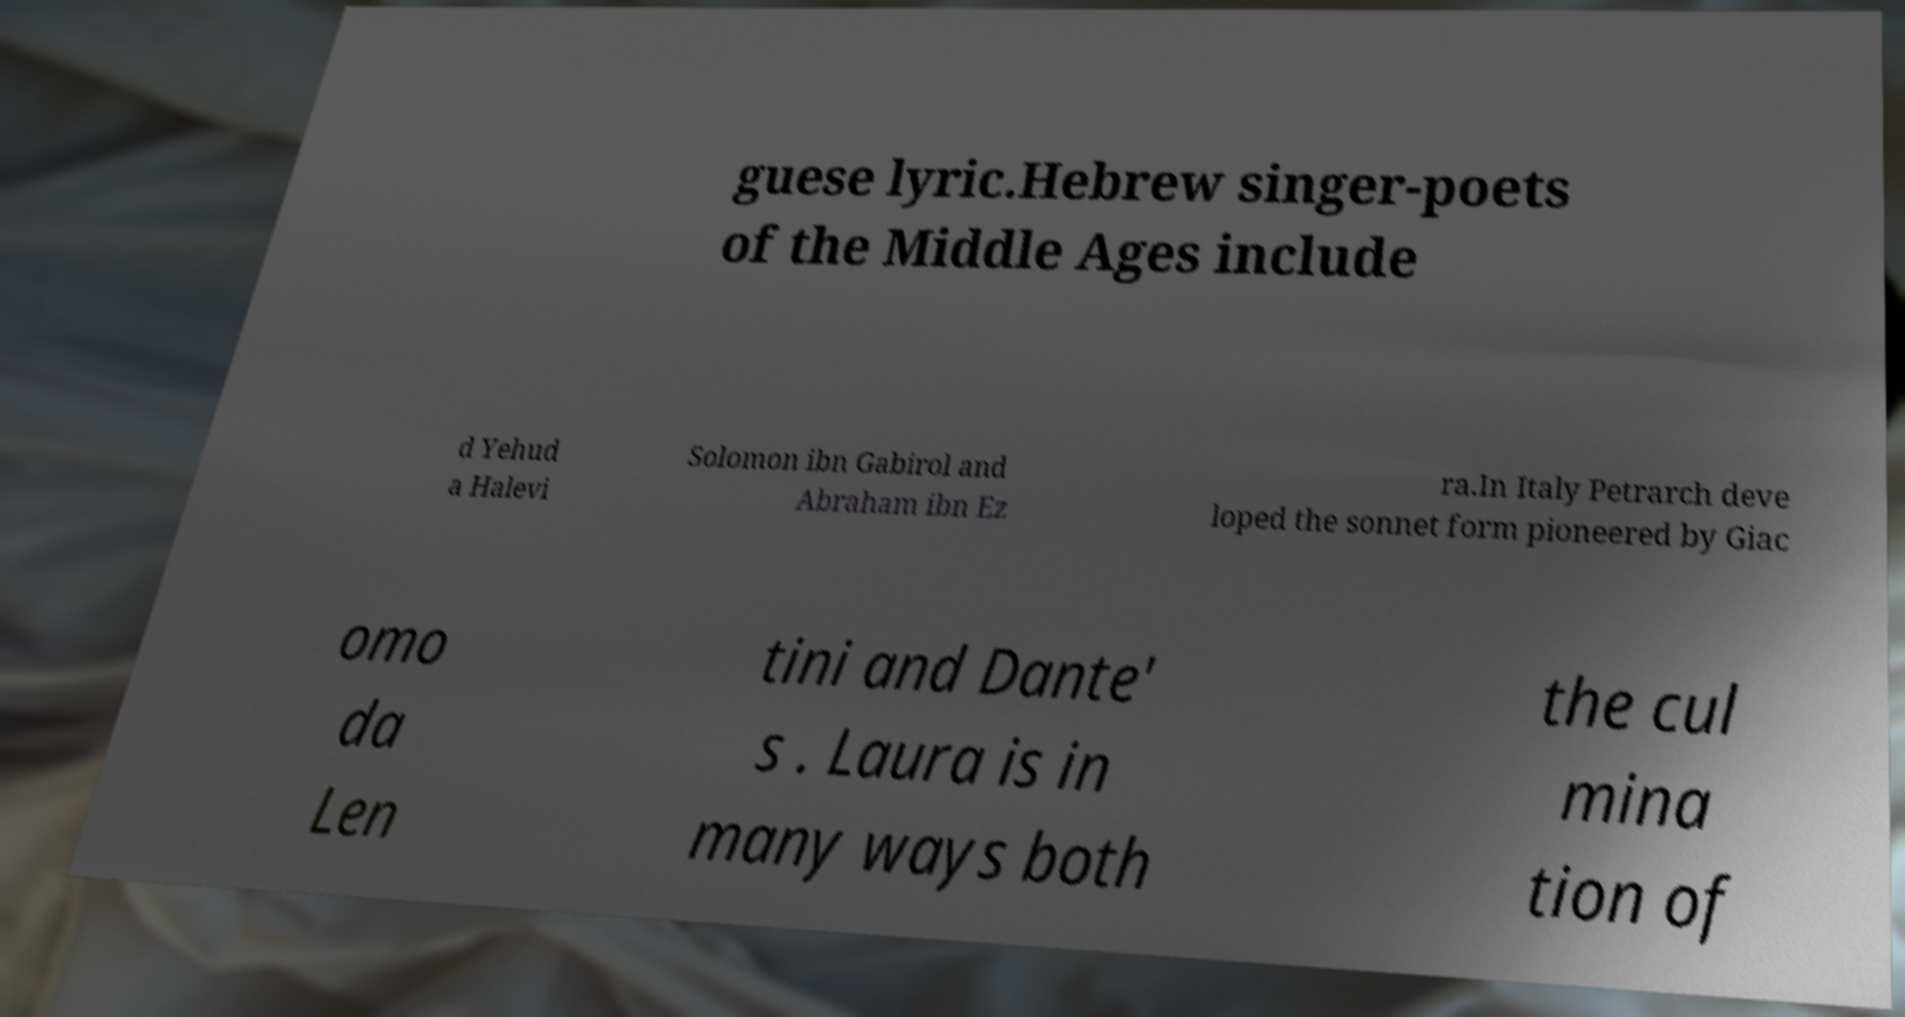Could you assist in decoding the text presented in this image and type it out clearly? guese lyric.Hebrew singer-poets of the Middle Ages include d Yehud a Halevi Solomon ibn Gabirol and Abraham ibn Ez ra.In Italy Petrarch deve loped the sonnet form pioneered by Giac omo da Len tini and Dante' s . Laura is in many ways both the cul mina tion of 